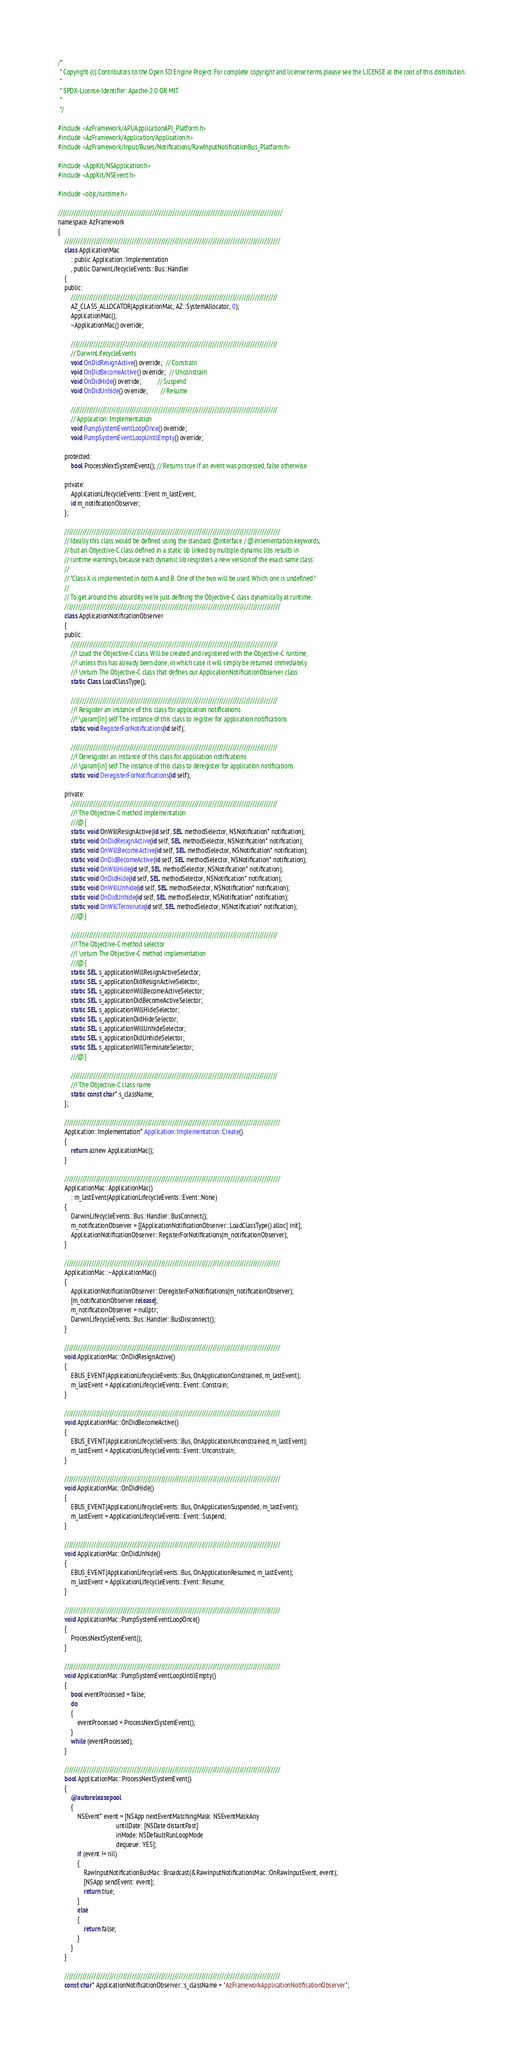Convert code to text. <code><loc_0><loc_0><loc_500><loc_500><_ObjectiveC_>/*
 * Copyright (c) Contributors to the Open 3D Engine Project. For complete copyright and license terms please see the LICENSE at the root of this distribution.
 * 
 * SPDX-License-Identifier: Apache-2.0 OR MIT
 *
 */

#include <AzFramework/API/ApplicationAPI_Platform.h>
#include <AzFramework/Application/Application.h>
#include <AzFramework/Input/Buses/Notifications/RawInputNotificationBus_Platform.h>

#include <AppKit/NSApplication.h>
#include <AppKit/NSEvent.h>

#include <objc/runtime.h>

////////////////////////////////////////////////////////////////////////////////////////////////////
namespace AzFramework
{
    ////////////////////////////////////////////////////////////////////////////////////////////////
    class ApplicationMac
        : public Application::Implementation
        , public DarwinLifecycleEvents::Bus::Handler
    {
    public:
        ////////////////////////////////////////////////////////////////////////////////////////////
        AZ_CLASS_ALLOCATOR(ApplicationMac, AZ::SystemAllocator, 0);
        ApplicationMac();
        ~ApplicationMac() override;

        ////////////////////////////////////////////////////////////////////////////////////////////
        // DarwinLifecycleEvents
        void OnDidResignActive() override;  // Constrain
        void OnDidBecomeActive() override;  // Unconstrain
        void OnDidHide() override;          // Suspend
        void OnDidUnhide() override;        // Resume

        ////////////////////////////////////////////////////////////////////////////////////////////
        // Application::Implementation
        void PumpSystemEventLoopOnce() override;
        void PumpSystemEventLoopUntilEmpty() override;

    protected:
        bool ProcessNextSystemEvent(); // Returns true if an event was processed, false otherwise

    private:
        ApplicationLifecycleEvents::Event m_lastEvent;
        id m_notificationObserver;
    };

    ////////////////////////////////////////////////////////////////////////////////////////////////
    // Ideally this class would be defined using the standard @interface / @imlementation keywords,
    // but an Objective-C class defined in a static lib linked by multiple dynamic libs results in
    // runtime warnings, because each dynamic lib resgisters a new version of the exact same class:
    //
    // "Class X is implemented in both A and B. One of the two will be used. Which one is undefined."
    //
    // To get around this absurdity we're just defining the Objective-C class dynamically at runtime.
    ////////////////////////////////////////////////////////////////////////////////////////////////
    class ApplicationNotificationObserver
    {
    public:
        ////////////////////////////////////////////////////////////////////////////////////////////
        //! Load the Objective-C class. Will be created and registered with the Objective-C runtime,
        //! unless this has already been done, in which case it will simply be returned immediately.
        //! \return The Objective-C class that defines our ApplicationNotificationObserver class
        static Class LoadClassType();

        ////////////////////////////////////////////////////////////////////////////////////////////
        //! Resgister an instance of this class for application notifications
        //! \param[in] self The instance of this class to register for application notifications
        static void RegisterForNotifications(id self);

        ////////////////////////////////////////////////////////////////////////////////////////////
        //! Deresgister an instance of this class for application notifications
        //! \param[in] self The instance of this class to deregister for application notifications
        static void DeregisterForNotifications(id self);

    private:
        ////////////////////////////////////////////////////////////////////////////////////////////
        //! The Objective-C method implementation
        ///@{
        static void OnWillResignActive(id self, SEL methodSelector, NSNotification* notification);
        static void OnDidResignActive(id self, SEL methodSelector, NSNotification* notification);
        static void OnWillBecomeActive(id self, SEL methodSelector, NSNotification* notification);
        static void OnDidBecomeActive(id self, SEL methodSelector, NSNotification* notification);
        static void OnWillHide(id self, SEL methodSelector, NSNotification* notification);
        static void OnDidHide(id self, SEL methodSelector, NSNotification* notification);
        static void OnWillUnhide(id self, SEL methodSelector, NSNotification* notification);
        static void OnDidUnhide(id self, SEL methodSelector, NSNotification* notification);
        static void OnWillTerminate(id self, SEL methodSelector, NSNotification* notification);
        ///@}

        ////////////////////////////////////////////////////////////////////////////////////////////
        //! The Objective-C method selector
        //! \return The Objective-C method implementation
        ///@{
        static SEL s_applicationWillResignActiveSelector;
        static SEL s_applicationDidResignActiveSelector;
        static SEL s_applicationWillBecomeActiveSelector;
        static SEL s_applicationDidBecomeActiveSelector;
        static SEL s_applicationWillHideSelector;
        static SEL s_applicationDidHideSelector;
        static SEL s_applicationWillUnhideSelector;
        static SEL s_applicationDidUnhideSelector;
        static SEL s_applicationWillTerminateSelector;
        ///@}

        ////////////////////////////////////////////////////////////////////////////////////////////
        //! The Objective-C class name
        static const char* s_className;
    };

    ////////////////////////////////////////////////////////////////////////////////////////////////
    Application::Implementation* Application::Implementation::Create()
    {
        return aznew ApplicationMac();
    }

    ////////////////////////////////////////////////////////////////////////////////////////////////
    ApplicationMac::ApplicationMac()
        : m_lastEvent(ApplicationLifecycleEvents::Event::None)
    {
        DarwinLifecycleEvents::Bus::Handler::BusConnect();
        m_notificationObserver = [[ApplicationNotificationObserver::LoadClassType() alloc] init];
        ApplicationNotificationObserver::RegisterForNotifications(m_notificationObserver);
    }

    ////////////////////////////////////////////////////////////////////////////////////////////////
    ApplicationMac::~ApplicationMac()
    {
        ApplicationNotificationObserver::DeregisterForNotifications(m_notificationObserver);
        [m_notificationObserver release];
        m_notificationObserver = nullptr;
        DarwinLifecycleEvents::Bus::Handler::BusDisconnect();
    }

    ////////////////////////////////////////////////////////////////////////////////////////////////
    void ApplicationMac::OnDidResignActive()
    {
        EBUS_EVENT(ApplicationLifecycleEvents::Bus, OnApplicationConstrained, m_lastEvent);
        m_lastEvent = ApplicationLifecycleEvents::Event::Constrain;
    }

    ////////////////////////////////////////////////////////////////////////////////////////////////
    void ApplicationMac::OnDidBecomeActive()
    {
        EBUS_EVENT(ApplicationLifecycleEvents::Bus, OnApplicationUnconstrained, m_lastEvent);
        m_lastEvent = ApplicationLifecycleEvents::Event::Unconstrain;
    }

    ////////////////////////////////////////////////////////////////////////////////////////////////
    void ApplicationMac::OnDidHide()
    {
        EBUS_EVENT(ApplicationLifecycleEvents::Bus, OnApplicationSuspended, m_lastEvent);
        m_lastEvent = ApplicationLifecycleEvents::Event::Suspend;
    }

    ////////////////////////////////////////////////////////////////////////////////////////////////
    void ApplicationMac::OnDidUnhide()
    {
        EBUS_EVENT(ApplicationLifecycleEvents::Bus, OnApplicationResumed, m_lastEvent);
        m_lastEvent = ApplicationLifecycleEvents::Event::Resume;
    }

    ////////////////////////////////////////////////////////////////////////////////////////////////
    void ApplicationMac::PumpSystemEventLoopOnce()
    {
        ProcessNextSystemEvent();
    }

    ////////////////////////////////////////////////////////////////////////////////////////////////
    void ApplicationMac::PumpSystemEventLoopUntilEmpty()
    {
        bool eventProcessed = false;
        do
        {
            eventProcessed = ProcessNextSystemEvent();
        }
        while (eventProcessed);
    }

    ////////////////////////////////////////////////////////////////////////////////////////////////
    bool ApplicationMac::ProcessNextSystemEvent()
    {
        @autoreleasepool
        {
            NSEvent* event = [NSApp nextEventMatchingMask: NSEventMaskAny
                                    untilDate: [NSDate distantPast]
                                    inMode: NSDefaultRunLoopMode
                                    dequeue: YES];
            if (event != nil)
            {
                RawInputNotificationBusMac::Broadcast(&RawInputNotificationsMac::OnRawInputEvent, event);
                [NSApp sendEvent: event];
                return true;
            }
            else
            {
                return false;
            }
        }
    }

    ////////////////////////////////////////////////////////////////////////////////////////////////
    const char* ApplicationNotificationObserver::s_className = "AzFrameworkApplicationNotificationObserver";</code> 